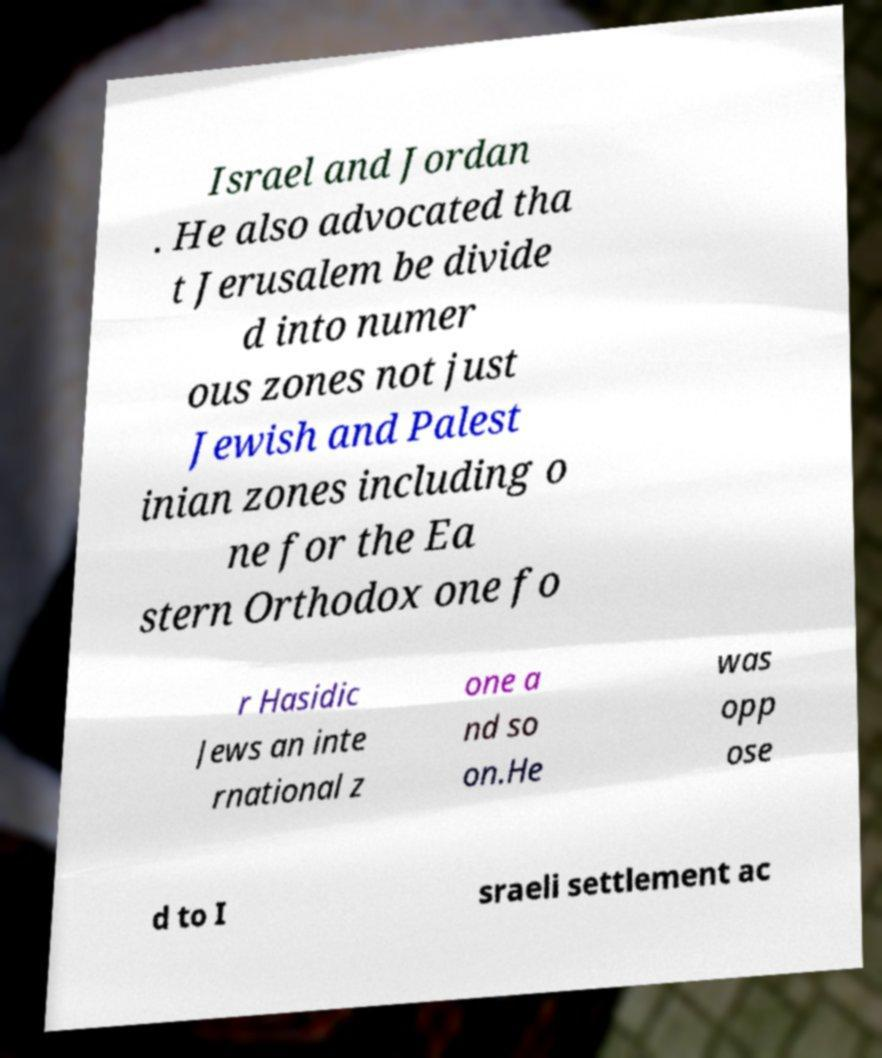For documentation purposes, I need the text within this image transcribed. Could you provide that? Israel and Jordan . He also advocated tha t Jerusalem be divide d into numer ous zones not just Jewish and Palest inian zones including o ne for the Ea stern Orthodox one fo r Hasidic Jews an inte rnational z one a nd so on.He was opp ose d to I sraeli settlement ac 